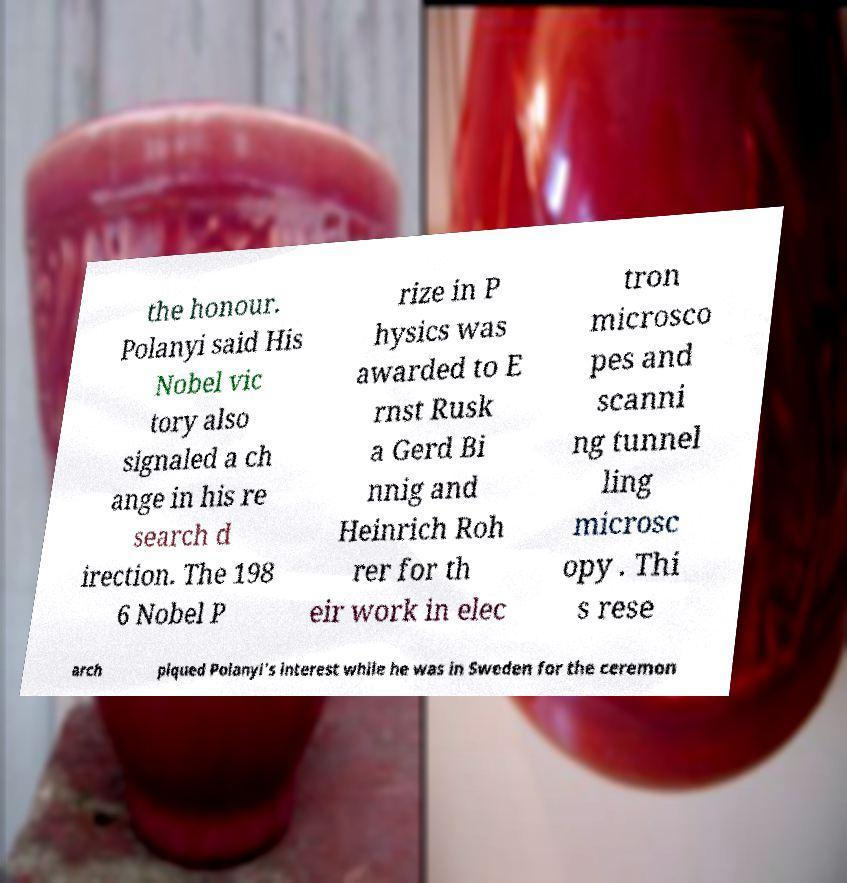Could you extract and type out the text from this image? the honour. Polanyi said His Nobel vic tory also signaled a ch ange in his re search d irection. The 198 6 Nobel P rize in P hysics was awarded to E rnst Rusk a Gerd Bi nnig and Heinrich Roh rer for th eir work in elec tron microsco pes and scanni ng tunnel ling microsc opy . Thi s rese arch piqued Polanyi's interest while he was in Sweden for the ceremon 